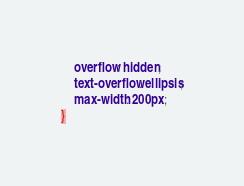Convert code to text. <code><loc_0><loc_0><loc_500><loc_500><_CSS_>    overflow: hidden;
    text-overflow: ellipsis;
    max-width: 200px;
}</code> 